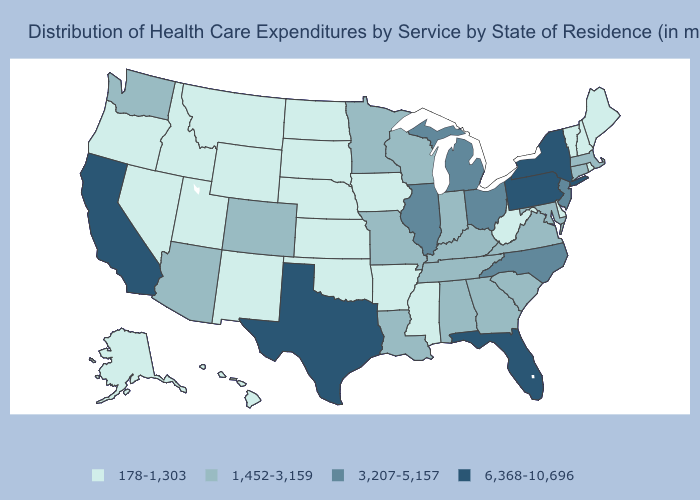What is the highest value in states that border Kansas?
Answer briefly. 1,452-3,159. Which states have the highest value in the USA?
Short answer required. California, Florida, New York, Pennsylvania, Texas. Which states have the lowest value in the USA?
Give a very brief answer. Alaska, Arkansas, Delaware, Hawaii, Idaho, Iowa, Kansas, Maine, Mississippi, Montana, Nebraska, Nevada, New Hampshire, New Mexico, North Dakota, Oklahoma, Oregon, Rhode Island, South Dakota, Utah, Vermont, West Virginia, Wyoming. Which states have the lowest value in the USA?
Keep it brief. Alaska, Arkansas, Delaware, Hawaii, Idaho, Iowa, Kansas, Maine, Mississippi, Montana, Nebraska, Nevada, New Hampshire, New Mexico, North Dakota, Oklahoma, Oregon, Rhode Island, South Dakota, Utah, Vermont, West Virginia, Wyoming. Does Ohio have a lower value than Pennsylvania?
Quick response, please. Yes. Name the states that have a value in the range 1,452-3,159?
Keep it brief. Alabama, Arizona, Colorado, Connecticut, Georgia, Indiana, Kentucky, Louisiana, Maryland, Massachusetts, Minnesota, Missouri, South Carolina, Tennessee, Virginia, Washington, Wisconsin. Is the legend a continuous bar?
Short answer required. No. What is the lowest value in the USA?
Concise answer only. 178-1,303. Which states hav the highest value in the MidWest?
Concise answer only. Illinois, Michigan, Ohio. Does Michigan have a higher value than South Dakota?
Be succinct. Yes. What is the lowest value in the MidWest?
Concise answer only. 178-1,303. What is the value of Delaware?
Short answer required. 178-1,303. Which states have the highest value in the USA?
Write a very short answer. California, Florida, New York, Pennsylvania, Texas. Name the states that have a value in the range 1,452-3,159?
Short answer required. Alabama, Arizona, Colorado, Connecticut, Georgia, Indiana, Kentucky, Louisiana, Maryland, Massachusetts, Minnesota, Missouri, South Carolina, Tennessee, Virginia, Washington, Wisconsin. Among the states that border Georgia , does Florida have the highest value?
Give a very brief answer. Yes. 